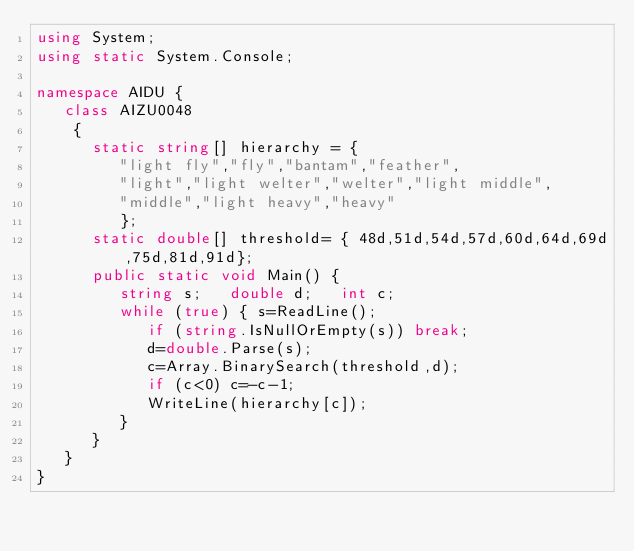Convert code to text. <code><loc_0><loc_0><loc_500><loc_500><_C#_>using System;
using static System.Console;

namespace AIDU {
   class AIZU0048
    {
      static string[] hierarchy = {
         "light fly","fly","bantam","feather",
         "light","light welter","welter","light middle",
         "middle","light heavy","heavy"
         };
      static double[] threshold= { 48d,51d,54d,57d,60d,64d,69d,75d,81d,91d};
      public static void Main() {
         string s;   double d;   int c;
         while (true) { s=ReadLine();
            if (string.IsNullOrEmpty(s)) break;
            d=double.Parse(s);
            c=Array.BinarySearch(threshold,d);
            if (c<0) c=-c-1;
            WriteLine(hierarchy[c]);
         }
      }
   }
}</code> 